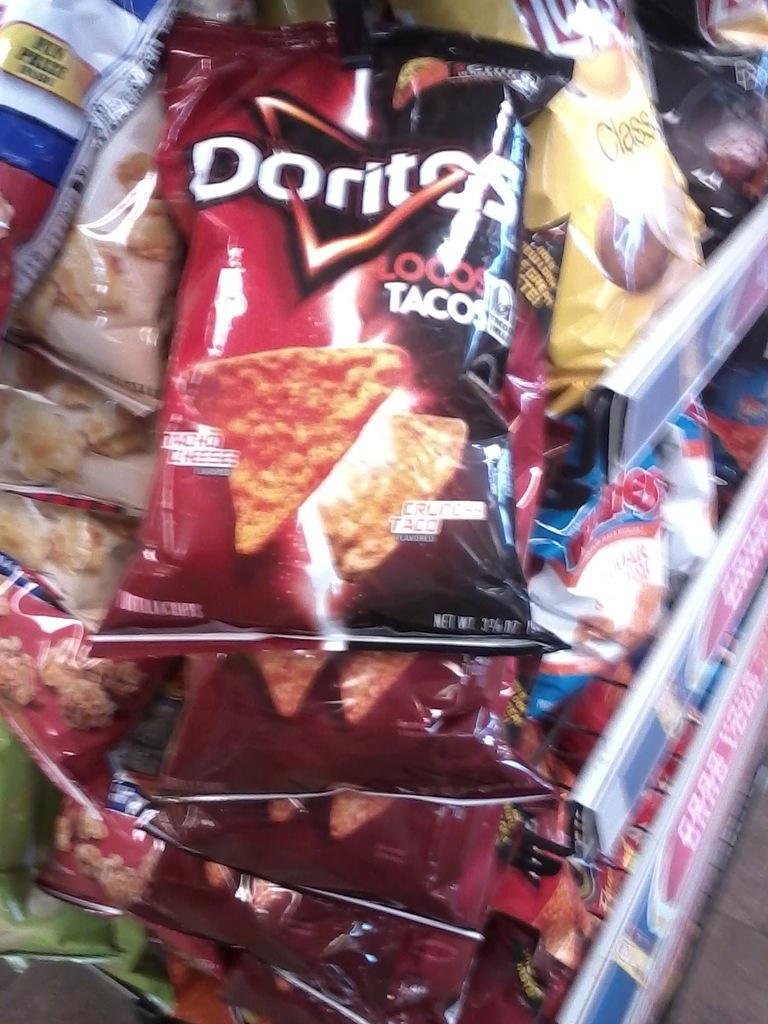<image>
Give a short and clear explanation of the subsequent image. Bags of Doritos Locos Tacos flavor chips are hanging on a rack. 